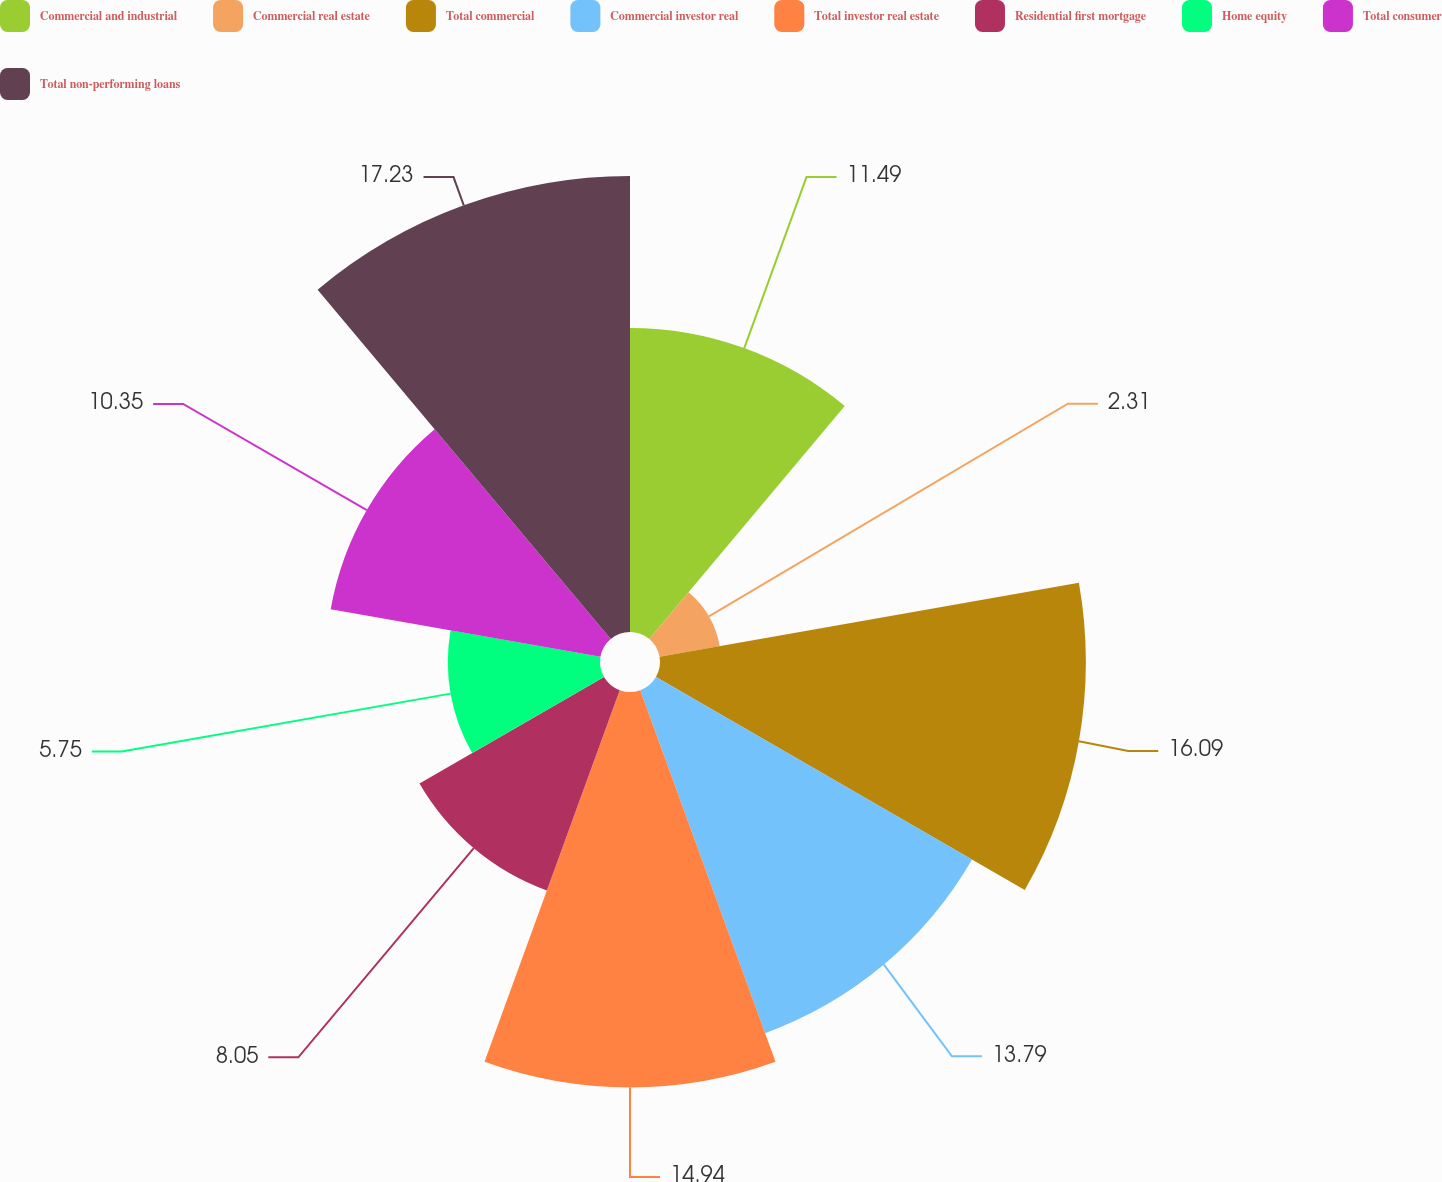Convert chart. <chart><loc_0><loc_0><loc_500><loc_500><pie_chart><fcel>Commercial and industrial<fcel>Commercial real estate<fcel>Total commercial<fcel>Commercial investor real<fcel>Total investor real estate<fcel>Residential first mortgage<fcel>Home equity<fcel>Total consumer<fcel>Total non-performing loans<nl><fcel>11.49%<fcel>2.31%<fcel>16.09%<fcel>13.79%<fcel>14.94%<fcel>8.05%<fcel>5.75%<fcel>10.35%<fcel>17.23%<nl></chart> 